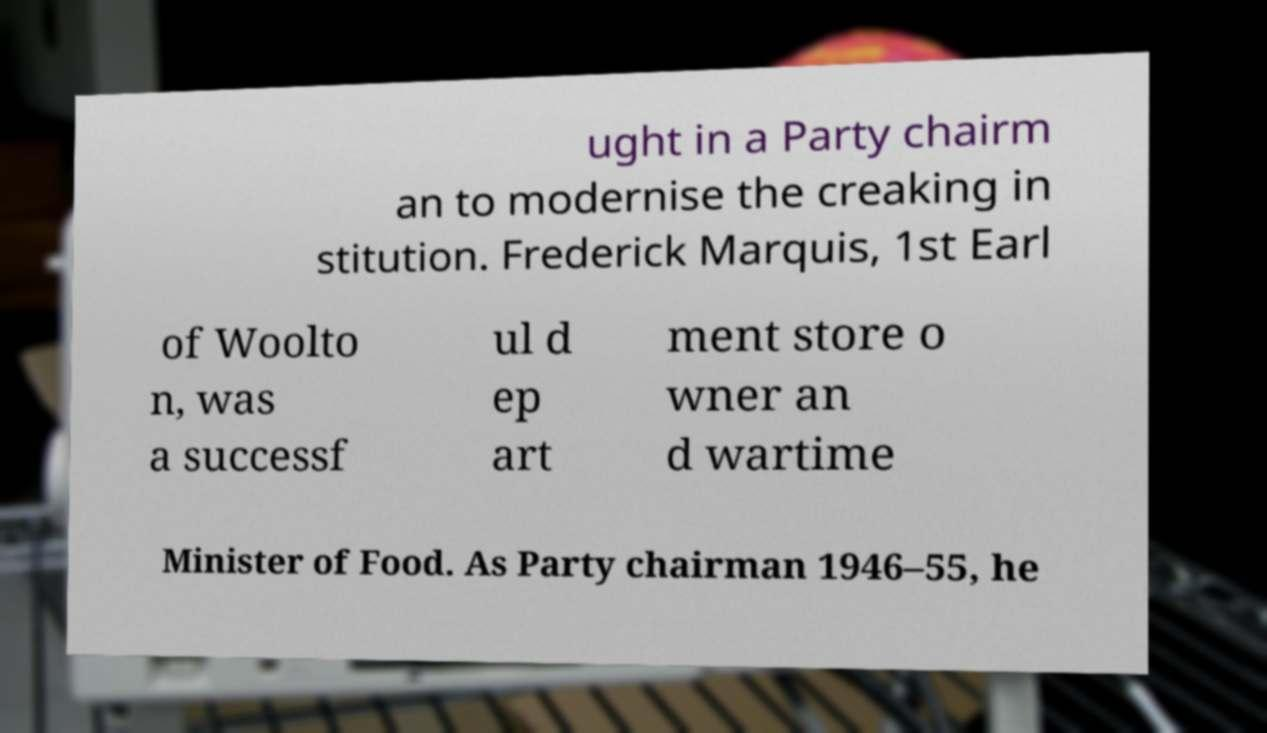I need the written content from this picture converted into text. Can you do that? ught in a Party chairm an to modernise the creaking in stitution. Frederick Marquis, 1st Earl of Woolto n, was a successf ul d ep art ment store o wner an d wartime Minister of Food. As Party chairman 1946–55, he 